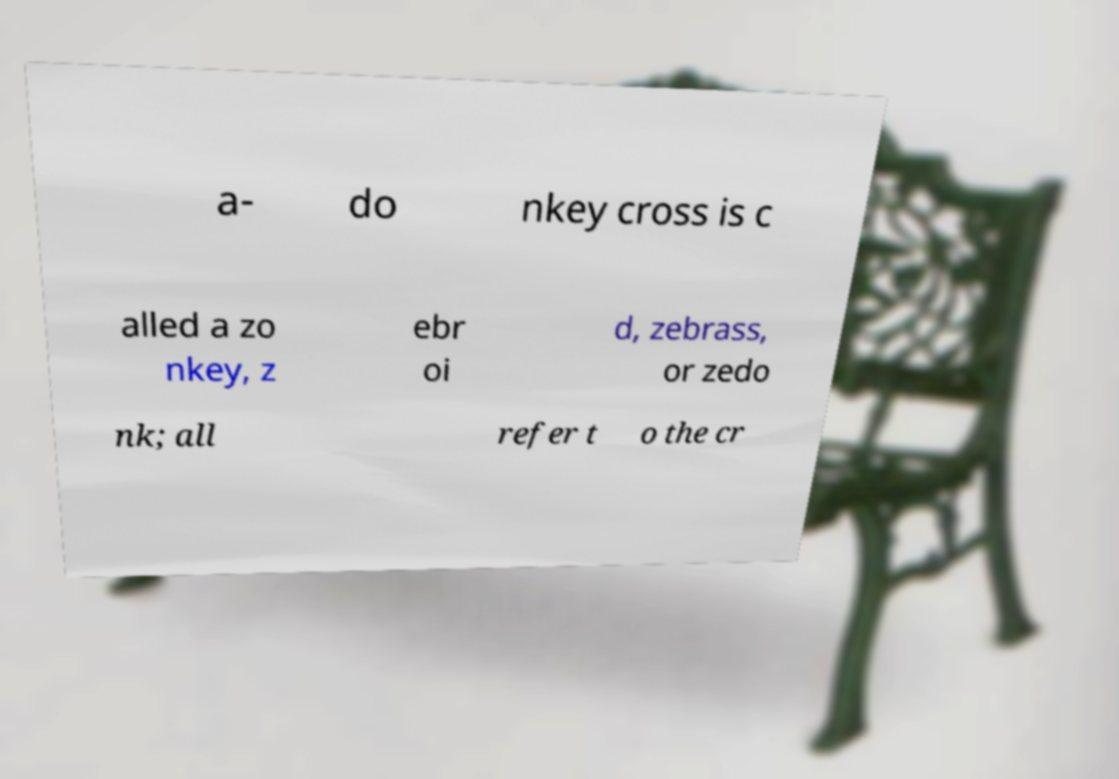I need the written content from this picture converted into text. Can you do that? a- do nkey cross is c alled a zo nkey, z ebr oi d, zebrass, or zedo nk; all refer t o the cr 